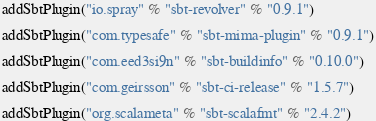Convert code to text. <code><loc_0><loc_0><loc_500><loc_500><_Scala_>
addSbtPlugin("io.spray" % "sbt-revolver" % "0.9.1")

addSbtPlugin("com.typesafe" % "sbt-mima-plugin" % "0.9.1")

addSbtPlugin("com.eed3si9n" % "sbt-buildinfo" % "0.10.0")

addSbtPlugin("com.geirsson" % "sbt-ci-release" % "1.5.7")

addSbtPlugin("org.scalameta" % "sbt-scalafmt" % "2.4.2")
</code> 